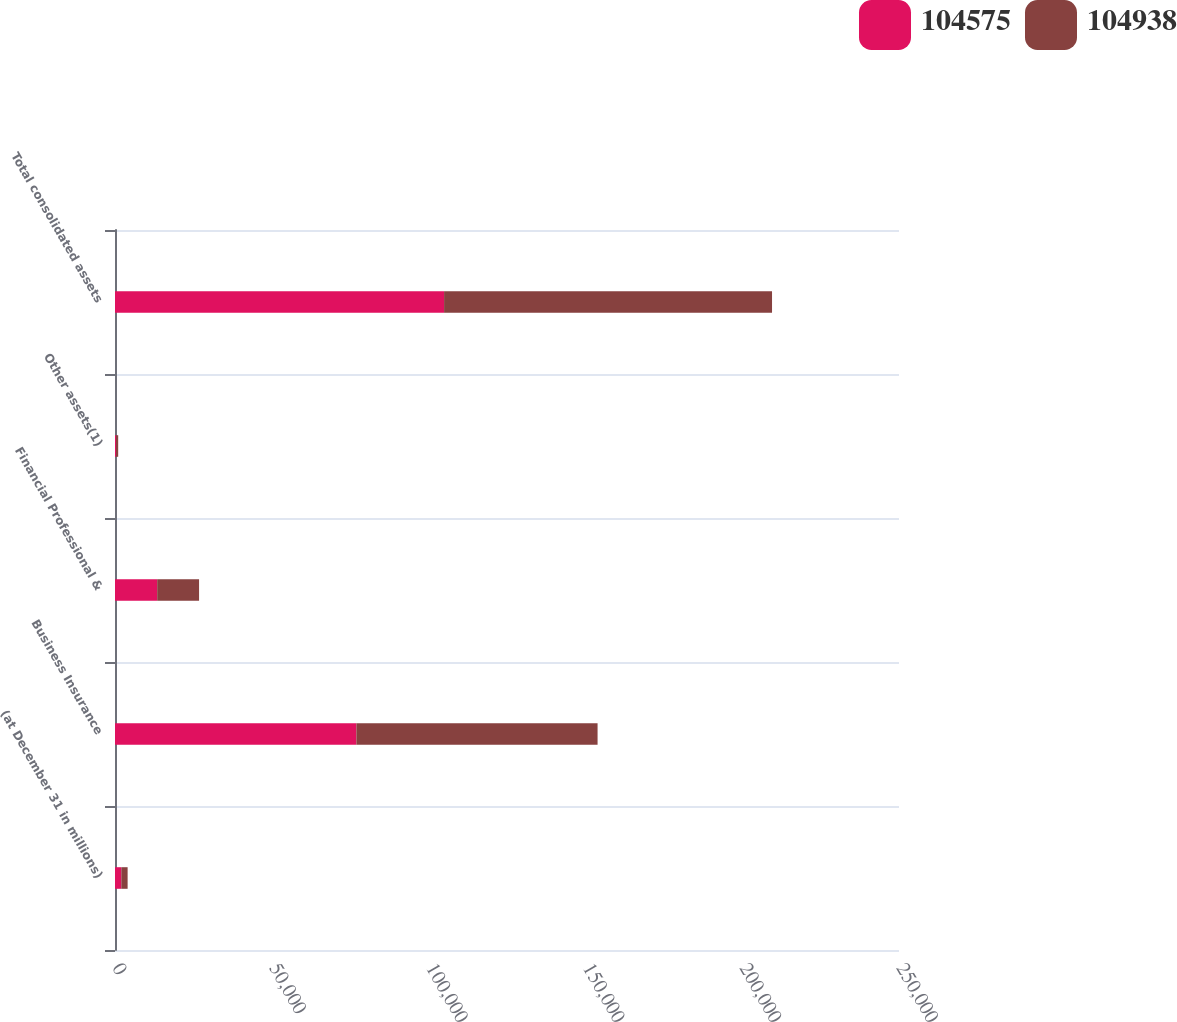Convert chart to OTSL. <chart><loc_0><loc_0><loc_500><loc_500><stacked_bar_chart><ecel><fcel>(at December 31 in millions)<fcel>Business Insurance<fcel>Financial Professional &<fcel>Other assets(1)<fcel>Total consolidated assets<nl><fcel>104575<fcel>2012<fcel>76972<fcel>13452<fcel>319<fcel>104938<nl><fcel>104938<fcel>2011<fcel>76909<fcel>13355<fcel>697<fcel>104575<nl></chart> 